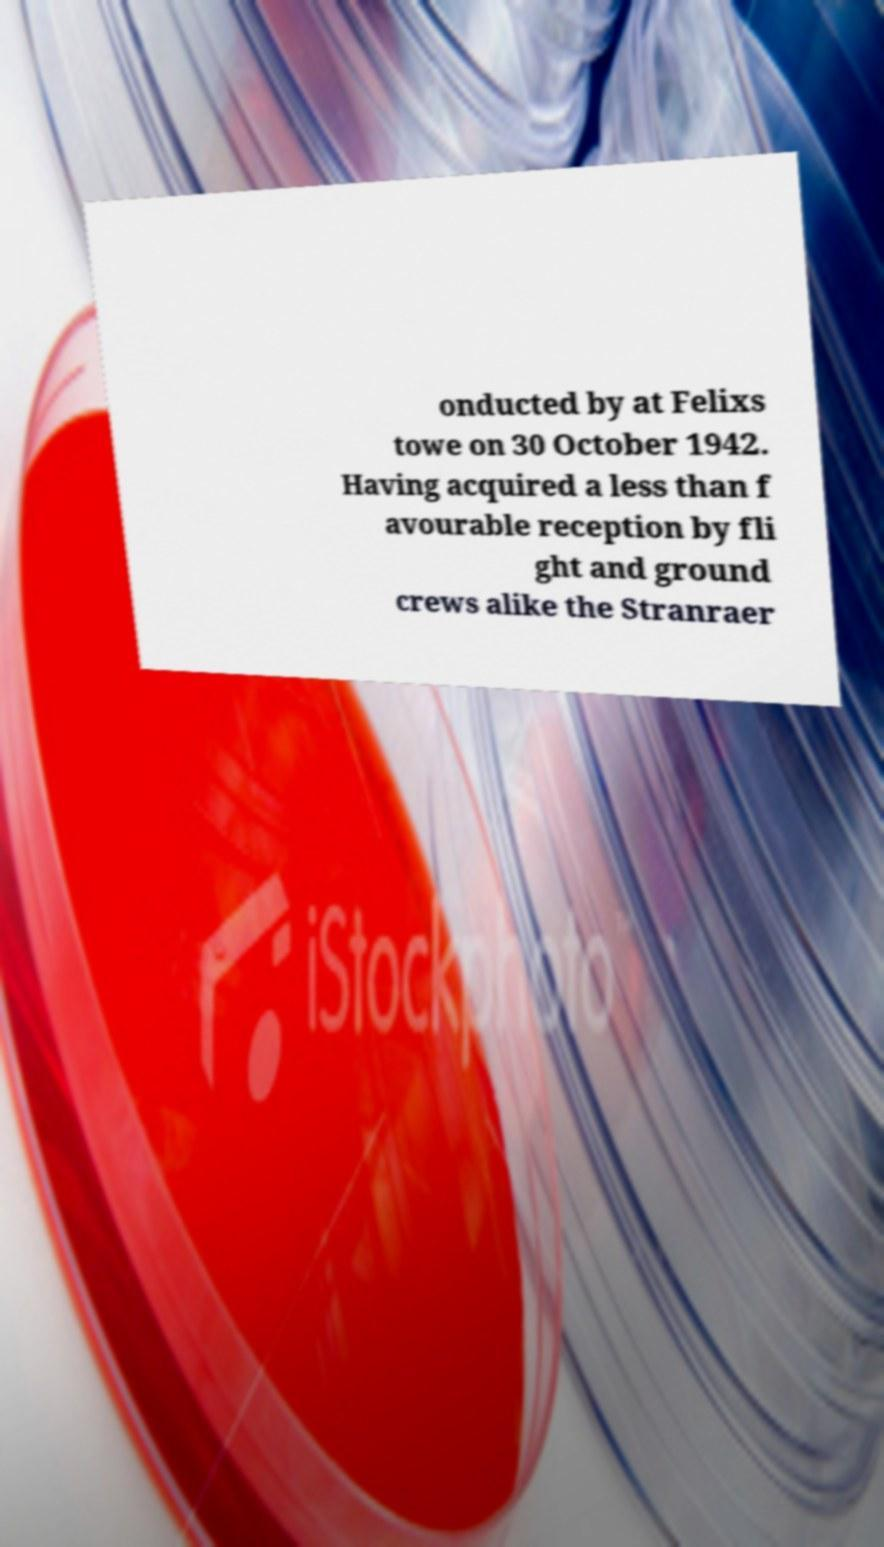Could you assist in decoding the text presented in this image and type it out clearly? onducted by at Felixs towe on 30 October 1942. Having acquired a less than f avourable reception by fli ght and ground crews alike the Stranraer 